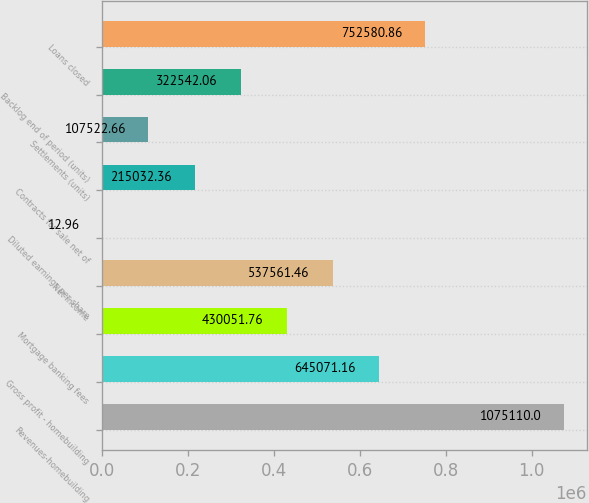<chart> <loc_0><loc_0><loc_500><loc_500><bar_chart><fcel>Revenues-homebuilding<fcel>Gross profit - homebuilding<fcel>Mortgage banking fees<fcel>Net income<fcel>Diluted earnings per share<fcel>Contracts for sale net of<fcel>Settlements (units)<fcel>Backlog end of period (units)<fcel>Loans closed<nl><fcel>1.07511e+06<fcel>645071<fcel>430052<fcel>537561<fcel>12.96<fcel>215032<fcel>107523<fcel>322542<fcel>752581<nl></chart> 